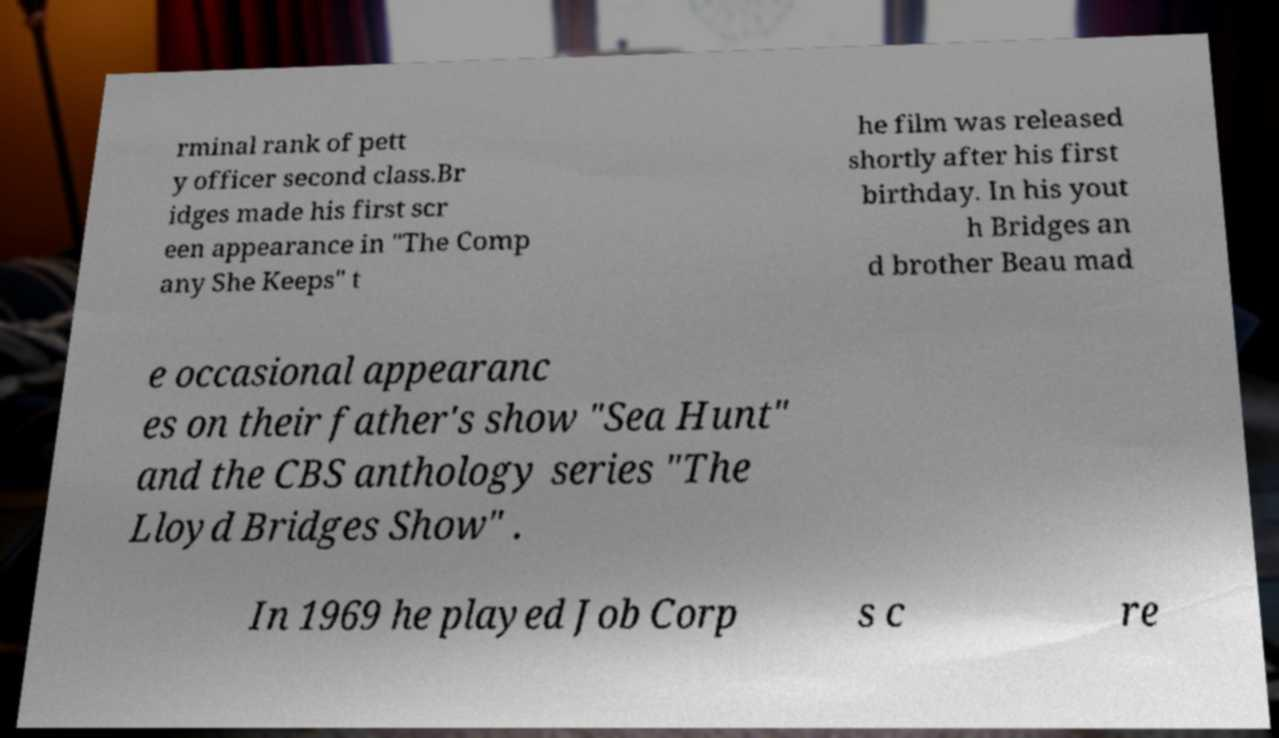Could you extract and type out the text from this image? rminal rank of pett y officer second class.Br idges made his first scr een appearance in "The Comp any She Keeps" t he film was released shortly after his first birthday. In his yout h Bridges an d brother Beau mad e occasional appearanc es on their father's show "Sea Hunt" and the CBS anthology series "The Lloyd Bridges Show" . In 1969 he played Job Corp s c re 